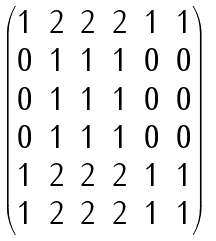<formula> <loc_0><loc_0><loc_500><loc_500>\begin{pmatrix} 1 & 2 & 2 & 2 & 1 & 1 \\ 0 & 1 & 1 & 1 & 0 & 0 \\ 0 & 1 & 1 & 1 & 0 & 0 \\ 0 & 1 & 1 & 1 & 0 & 0 \\ 1 & 2 & 2 & 2 & 1 & 1 \\ 1 & 2 & 2 & 2 & 1 & 1 \\ \end{pmatrix}</formula> 